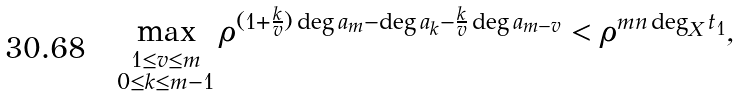<formula> <loc_0><loc_0><loc_500><loc_500>\max _ { _ { \substack { 1 \leq v \leq m \\ 0 \leq k \leq m - 1 } } } \rho ^ { ( 1 + \frac { k } { v } ) \deg a _ { m } - \deg a _ { k } - \frac { k } { v } \deg a _ { m - v } } < \rho ^ { m n \deg _ { X } t _ { 1 } } ,</formula> 